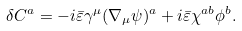<formula> <loc_0><loc_0><loc_500><loc_500>\delta C ^ { a } = - i \bar { \varepsilon } \gamma ^ { \mu } ( \nabla _ { \mu } \psi ) ^ { a } + i \bar { \varepsilon } \chi ^ { a b } \phi ^ { b } .</formula> 